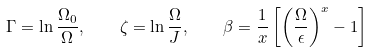<formula> <loc_0><loc_0><loc_500><loc_500>\Gamma = \ln \frac { \Omega _ { 0 } } { \Omega } , \quad \zeta = \ln \frac { \Omega } { J } , \quad \beta = \frac { 1 } { x } \left [ { \left ( \frac { \Omega } { \epsilon } \right ) } ^ { x } - 1 \right ]</formula> 